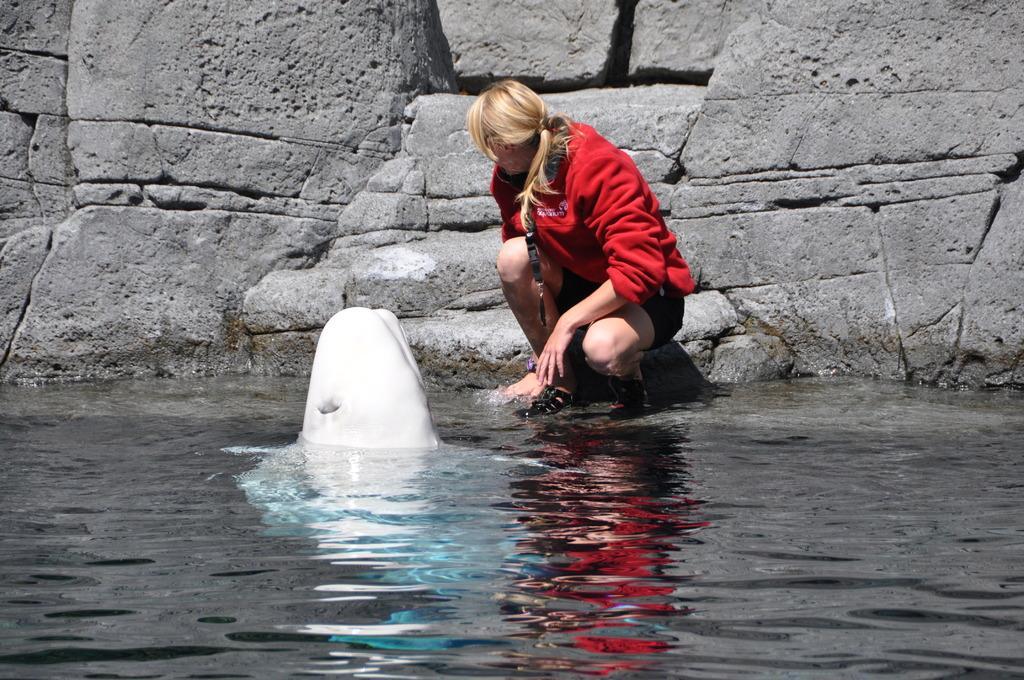How would you summarize this image in a sentence or two? In this image in the center there is water and in the water there is an aquatic animal and in the background there is a woman and there is a wall. 